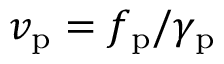<formula> <loc_0><loc_0><loc_500><loc_500>v _ { p } = f _ { p } / \gamma _ { p }</formula> 